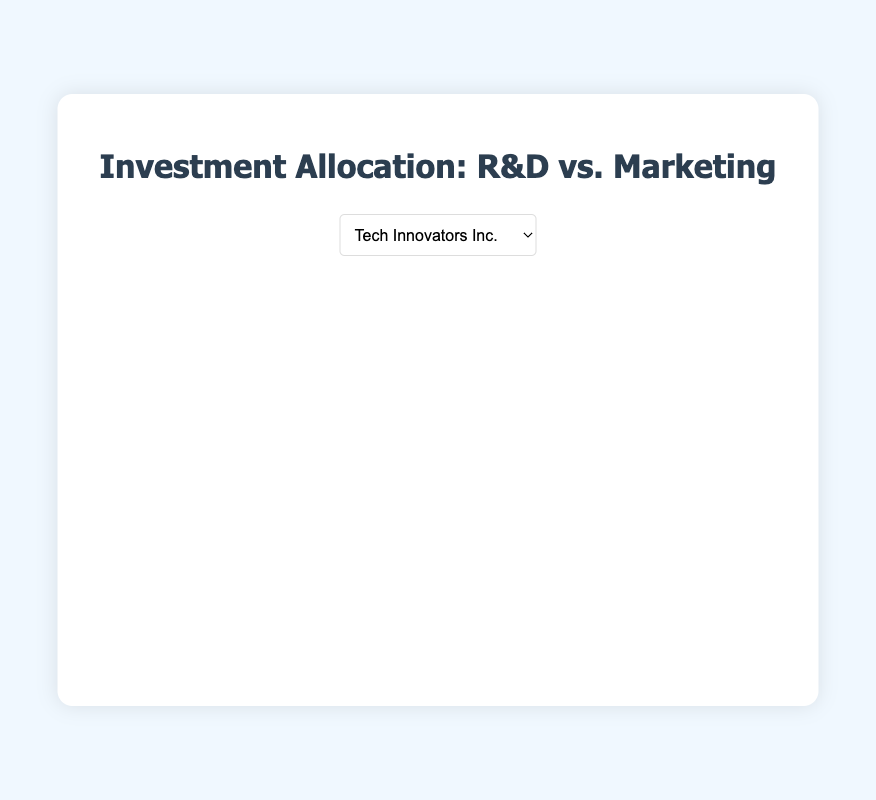Which company allocates the highest percentage of its investment to R&D? By examining the pie charts for each company, we directly compare the R&D percentages. Future Tech Solutions has the highest R&D allocation at 70%.
Answer: Future Tech Solutions Which company has an equal allocation between R&D and Marketing? We need to identify the company where the percentages for R&D and Marketing are both 50%. Digital Pioneer Corp. shows an equal allocation of 50% each.
Answer: Digital Pioneer Corp How much more does Tech Innovators Inc. invest in R&D compared to Marketing? For Tech Innovators Inc., the allocation for R&D is 60% and for Marketing is 40%. The difference is 60% - 40% = 20%.
Answer: 20% Which company's pie chart would visually show the smallest segment for Marketing? To find the smallest segment, we compare the Marketing percentages. The smallest Marketing percentage is 30%, found at Future Tech Solutions.
Answer: Future Tech Solutions If we average the R&D investments across all companies, what is the result? To find the average, we sum up all R&D percentages and divide by the number of companies: (60% + 50% + 70% + 55% + 65%)/5 = 60%.
Answer: 60% Compare the R&D investment of Cloud Catalyst Ltd. and NetSavvy Enterprises. Which company invests more in R&D and by how much? Cloud Catalyst Ltd. invests 65% in R&D while NetSavvy Enterprises invests 55%. The difference is 65% - 55% = 10%.
Answer: Cloud Catalyst Ltd. by 10% What is the overall investment allocation difference between Marketing for Tech Innovators Inc. and Future Tech Solutions? Tech Innovators Inc.'s Marketing allocation is 40% and Future Tech Solutions' is 30%. The difference is 40% - 30% = 10%.
Answer: 10% Which company would have the most evenly distributed segments in its pie chart? An evenly distributed pie chart would have segments that are closest in size. Digital Pioneer Corp. is the most evenly distributed with 50% for both R&D and Marketing.
Answer: Digital Pioneer Corp If we combine the R&D percentages for NetSavvy Enterprises and Cloud Catalyst Ltd., what would be the total? Summing the R&D investments of NetSavvy Enterprises (55%) and Cloud Catalyst Ltd. (65%): 55% + 65% = 120%.
Answer: 120% Based on the visual attributes of the pie chart, which company predominantly uses a red segment? The red segment represents Marketing. We need to find the company where the red segment is larger. By comparison, Tech Innovators Inc. and NetSavvy Enterprises have significant red segments, but Digital Pioneer Corp. has the largest red segment with 50%.
Answer: Digital Pioneer Corp 